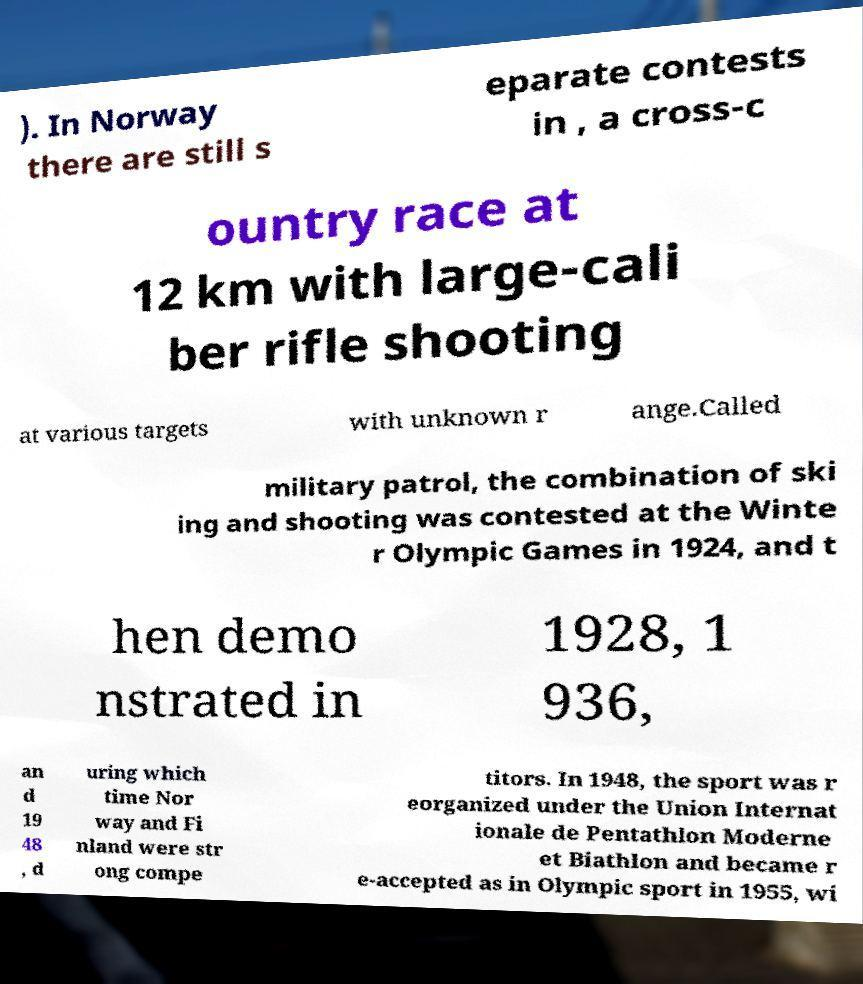For documentation purposes, I need the text within this image transcribed. Could you provide that? ). In Norway there are still s eparate contests in , a cross-c ountry race at 12 km with large-cali ber rifle shooting at various targets with unknown r ange.Called military patrol, the combination of ski ing and shooting was contested at the Winte r Olympic Games in 1924, and t hen demo nstrated in 1928, 1 936, an d 19 48 , d uring which time Nor way and Fi nland were str ong compe titors. In 1948, the sport was r eorganized under the Union Internat ionale de Pentathlon Moderne et Biathlon and became r e-accepted as in Olympic sport in 1955, wi 